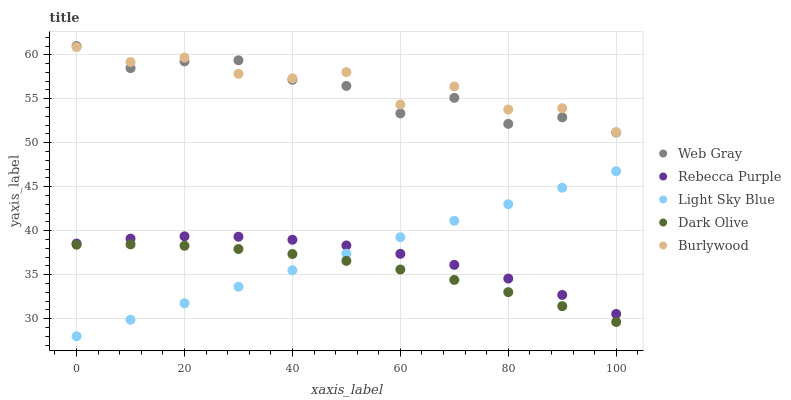Does Dark Olive have the minimum area under the curve?
Answer yes or no. Yes. Does Burlywood have the maximum area under the curve?
Answer yes or no. Yes. Does Web Gray have the minimum area under the curve?
Answer yes or no. No. Does Web Gray have the maximum area under the curve?
Answer yes or no. No. Is Light Sky Blue the smoothest?
Answer yes or no. Yes. Is Burlywood the roughest?
Answer yes or no. Yes. Is Web Gray the smoothest?
Answer yes or no. No. Is Web Gray the roughest?
Answer yes or no. No. Does Light Sky Blue have the lowest value?
Answer yes or no. Yes. Does Web Gray have the lowest value?
Answer yes or no. No. Does Web Gray have the highest value?
Answer yes or no. Yes. Does Burlywood have the highest value?
Answer yes or no. No. Is Dark Olive less than Burlywood?
Answer yes or no. Yes. Is Rebecca Purple greater than Dark Olive?
Answer yes or no. Yes. Does Rebecca Purple intersect Light Sky Blue?
Answer yes or no. Yes. Is Rebecca Purple less than Light Sky Blue?
Answer yes or no. No. Is Rebecca Purple greater than Light Sky Blue?
Answer yes or no. No. Does Dark Olive intersect Burlywood?
Answer yes or no. No. 